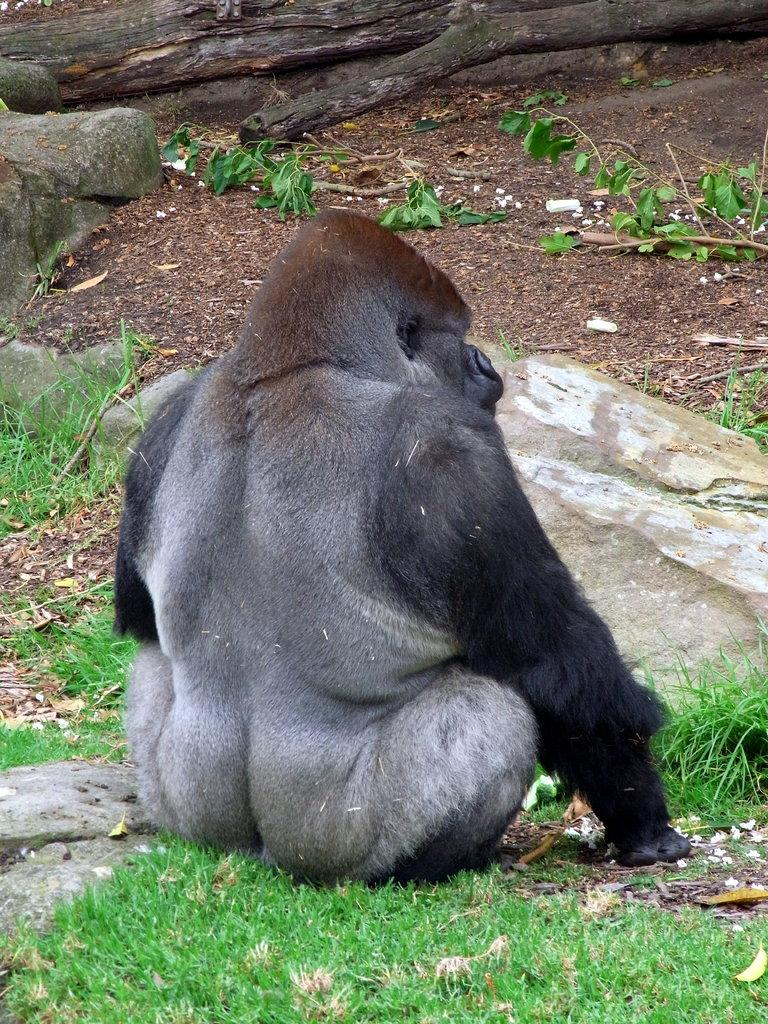What animal is sitting in the image? There is a chimpanzee sitting in the image. What natural object is present in the image? There is a tree trunk in the image. What else can be seen related to the tree in the image? There are tree branches in the image. What type of vegetation is visible in the image? There is grass in the image. What other objects can be found on the ground in the image? There are stones in the image. What color is the rose that the chimpanzee is holding in the image? There is no rose present in the image; the chimpanzee is not holding anything. 